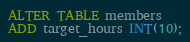<code> <loc_0><loc_0><loc_500><loc_500><_SQL_>ALTER TABLE members 
ADD target_hours INT(10);</code> 